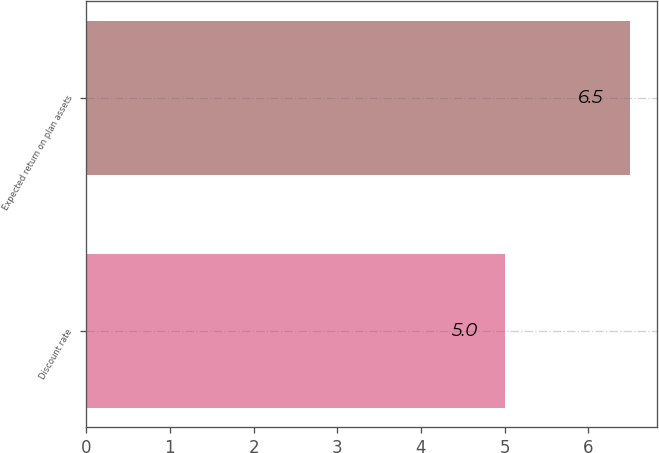Convert chart. <chart><loc_0><loc_0><loc_500><loc_500><bar_chart><fcel>Discount rate<fcel>Expected return on plan assets<nl><fcel>5<fcel>6.5<nl></chart> 